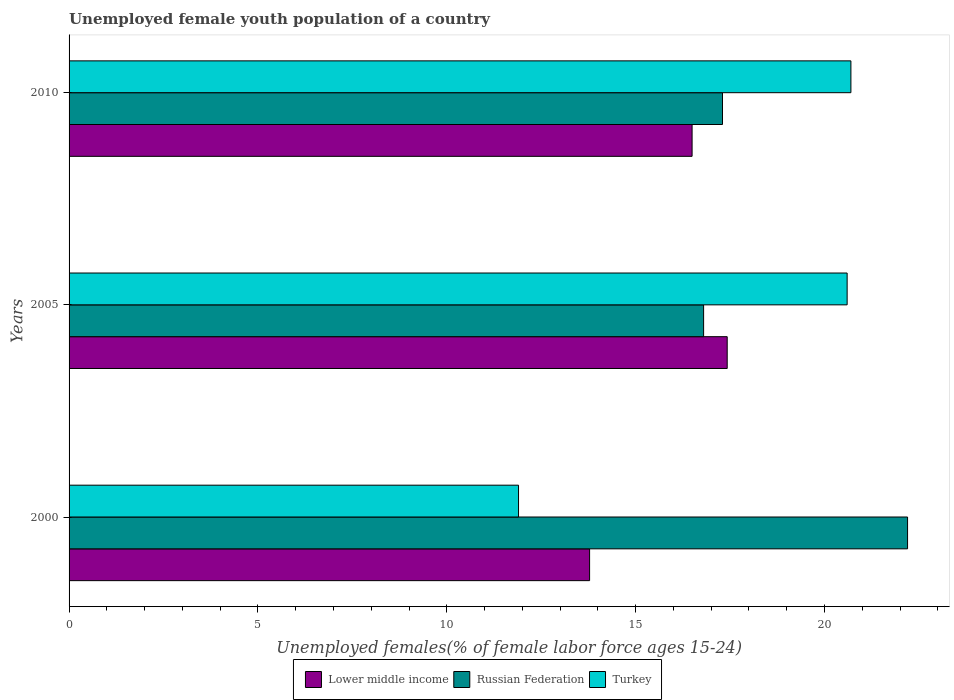How many different coloured bars are there?
Give a very brief answer. 3. How many bars are there on the 1st tick from the bottom?
Give a very brief answer. 3. What is the percentage of unemployed female youth population in Russian Federation in 2010?
Provide a succinct answer. 17.3. Across all years, what is the maximum percentage of unemployed female youth population in Lower middle income?
Ensure brevity in your answer.  17.42. Across all years, what is the minimum percentage of unemployed female youth population in Turkey?
Make the answer very short. 11.9. In which year was the percentage of unemployed female youth population in Lower middle income maximum?
Ensure brevity in your answer.  2005. What is the total percentage of unemployed female youth population in Russian Federation in the graph?
Your response must be concise. 56.3. What is the difference between the percentage of unemployed female youth population in Turkey in 2005 and that in 2010?
Your answer should be very brief. -0.1. What is the difference between the percentage of unemployed female youth population in Russian Federation in 2010 and the percentage of unemployed female youth population in Turkey in 2000?
Offer a very short reply. 5.4. What is the average percentage of unemployed female youth population in Russian Federation per year?
Provide a succinct answer. 18.77. In the year 2005, what is the difference between the percentage of unemployed female youth population in Russian Federation and percentage of unemployed female youth population in Lower middle income?
Give a very brief answer. -0.62. In how many years, is the percentage of unemployed female youth population in Russian Federation greater than 18 %?
Ensure brevity in your answer.  1. What is the ratio of the percentage of unemployed female youth population in Russian Federation in 2000 to that in 2010?
Provide a short and direct response. 1.28. What is the difference between the highest and the second highest percentage of unemployed female youth population in Turkey?
Provide a succinct answer. 0.1. What is the difference between the highest and the lowest percentage of unemployed female youth population in Russian Federation?
Your answer should be compact. 5.4. In how many years, is the percentage of unemployed female youth population in Turkey greater than the average percentage of unemployed female youth population in Turkey taken over all years?
Give a very brief answer. 2. Is the sum of the percentage of unemployed female youth population in Turkey in 2005 and 2010 greater than the maximum percentage of unemployed female youth population in Russian Federation across all years?
Make the answer very short. Yes. What does the 2nd bar from the top in 2005 represents?
Your response must be concise. Russian Federation. What does the 2nd bar from the bottom in 2000 represents?
Your answer should be compact. Russian Federation. How many years are there in the graph?
Offer a very short reply. 3. What is the difference between two consecutive major ticks on the X-axis?
Give a very brief answer. 5. Does the graph contain any zero values?
Offer a terse response. No. Does the graph contain grids?
Provide a short and direct response. No. Where does the legend appear in the graph?
Offer a very short reply. Bottom center. How many legend labels are there?
Offer a terse response. 3. How are the legend labels stacked?
Give a very brief answer. Horizontal. What is the title of the graph?
Make the answer very short. Unemployed female youth population of a country. Does "New Zealand" appear as one of the legend labels in the graph?
Your response must be concise. No. What is the label or title of the X-axis?
Make the answer very short. Unemployed females(% of female labor force ages 15-24). What is the Unemployed females(% of female labor force ages 15-24) of Lower middle income in 2000?
Provide a succinct answer. 13.78. What is the Unemployed females(% of female labor force ages 15-24) in Russian Federation in 2000?
Provide a succinct answer. 22.2. What is the Unemployed females(% of female labor force ages 15-24) of Turkey in 2000?
Keep it short and to the point. 11.9. What is the Unemployed females(% of female labor force ages 15-24) in Lower middle income in 2005?
Provide a succinct answer. 17.42. What is the Unemployed females(% of female labor force ages 15-24) in Russian Federation in 2005?
Keep it short and to the point. 16.8. What is the Unemployed females(% of female labor force ages 15-24) in Turkey in 2005?
Make the answer very short. 20.6. What is the Unemployed females(% of female labor force ages 15-24) of Lower middle income in 2010?
Provide a short and direct response. 16.49. What is the Unemployed females(% of female labor force ages 15-24) in Russian Federation in 2010?
Keep it short and to the point. 17.3. What is the Unemployed females(% of female labor force ages 15-24) of Turkey in 2010?
Ensure brevity in your answer.  20.7. Across all years, what is the maximum Unemployed females(% of female labor force ages 15-24) of Lower middle income?
Offer a terse response. 17.42. Across all years, what is the maximum Unemployed females(% of female labor force ages 15-24) of Russian Federation?
Your answer should be very brief. 22.2. Across all years, what is the maximum Unemployed females(% of female labor force ages 15-24) of Turkey?
Give a very brief answer. 20.7. Across all years, what is the minimum Unemployed females(% of female labor force ages 15-24) of Lower middle income?
Provide a succinct answer. 13.78. Across all years, what is the minimum Unemployed females(% of female labor force ages 15-24) of Russian Federation?
Offer a terse response. 16.8. Across all years, what is the minimum Unemployed females(% of female labor force ages 15-24) of Turkey?
Give a very brief answer. 11.9. What is the total Unemployed females(% of female labor force ages 15-24) of Lower middle income in the graph?
Your response must be concise. 47.7. What is the total Unemployed females(% of female labor force ages 15-24) of Russian Federation in the graph?
Make the answer very short. 56.3. What is the total Unemployed females(% of female labor force ages 15-24) of Turkey in the graph?
Offer a terse response. 53.2. What is the difference between the Unemployed females(% of female labor force ages 15-24) of Lower middle income in 2000 and that in 2005?
Provide a short and direct response. -3.64. What is the difference between the Unemployed females(% of female labor force ages 15-24) of Turkey in 2000 and that in 2005?
Offer a very short reply. -8.7. What is the difference between the Unemployed females(% of female labor force ages 15-24) of Lower middle income in 2000 and that in 2010?
Your answer should be very brief. -2.71. What is the difference between the Unemployed females(% of female labor force ages 15-24) of Russian Federation in 2000 and that in 2010?
Your answer should be compact. 4.9. What is the difference between the Unemployed females(% of female labor force ages 15-24) in Turkey in 2000 and that in 2010?
Your response must be concise. -8.8. What is the difference between the Unemployed females(% of female labor force ages 15-24) of Lower middle income in 2005 and that in 2010?
Your answer should be very brief. 0.93. What is the difference between the Unemployed females(% of female labor force ages 15-24) in Turkey in 2005 and that in 2010?
Your answer should be compact. -0.1. What is the difference between the Unemployed females(% of female labor force ages 15-24) in Lower middle income in 2000 and the Unemployed females(% of female labor force ages 15-24) in Russian Federation in 2005?
Give a very brief answer. -3.02. What is the difference between the Unemployed females(% of female labor force ages 15-24) of Lower middle income in 2000 and the Unemployed females(% of female labor force ages 15-24) of Turkey in 2005?
Provide a succinct answer. -6.82. What is the difference between the Unemployed females(% of female labor force ages 15-24) in Russian Federation in 2000 and the Unemployed females(% of female labor force ages 15-24) in Turkey in 2005?
Offer a terse response. 1.6. What is the difference between the Unemployed females(% of female labor force ages 15-24) in Lower middle income in 2000 and the Unemployed females(% of female labor force ages 15-24) in Russian Federation in 2010?
Your response must be concise. -3.52. What is the difference between the Unemployed females(% of female labor force ages 15-24) of Lower middle income in 2000 and the Unemployed females(% of female labor force ages 15-24) of Turkey in 2010?
Your response must be concise. -6.92. What is the difference between the Unemployed females(% of female labor force ages 15-24) of Lower middle income in 2005 and the Unemployed females(% of female labor force ages 15-24) of Russian Federation in 2010?
Offer a terse response. 0.12. What is the difference between the Unemployed females(% of female labor force ages 15-24) of Lower middle income in 2005 and the Unemployed females(% of female labor force ages 15-24) of Turkey in 2010?
Offer a terse response. -3.28. What is the difference between the Unemployed females(% of female labor force ages 15-24) in Russian Federation in 2005 and the Unemployed females(% of female labor force ages 15-24) in Turkey in 2010?
Provide a short and direct response. -3.9. What is the average Unemployed females(% of female labor force ages 15-24) of Lower middle income per year?
Ensure brevity in your answer.  15.9. What is the average Unemployed females(% of female labor force ages 15-24) of Russian Federation per year?
Ensure brevity in your answer.  18.77. What is the average Unemployed females(% of female labor force ages 15-24) in Turkey per year?
Your answer should be compact. 17.73. In the year 2000, what is the difference between the Unemployed females(% of female labor force ages 15-24) in Lower middle income and Unemployed females(% of female labor force ages 15-24) in Russian Federation?
Provide a short and direct response. -8.42. In the year 2000, what is the difference between the Unemployed females(% of female labor force ages 15-24) in Lower middle income and Unemployed females(% of female labor force ages 15-24) in Turkey?
Provide a short and direct response. 1.88. In the year 2000, what is the difference between the Unemployed females(% of female labor force ages 15-24) in Russian Federation and Unemployed females(% of female labor force ages 15-24) in Turkey?
Your response must be concise. 10.3. In the year 2005, what is the difference between the Unemployed females(% of female labor force ages 15-24) in Lower middle income and Unemployed females(% of female labor force ages 15-24) in Russian Federation?
Provide a short and direct response. 0.62. In the year 2005, what is the difference between the Unemployed females(% of female labor force ages 15-24) of Lower middle income and Unemployed females(% of female labor force ages 15-24) of Turkey?
Your response must be concise. -3.18. In the year 2005, what is the difference between the Unemployed females(% of female labor force ages 15-24) in Russian Federation and Unemployed females(% of female labor force ages 15-24) in Turkey?
Ensure brevity in your answer.  -3.8. In the year 2010, what is the difference between the Unemployed females(% of female labor force ages 15-24) in Lower middle income and Unemployed females(% of female labor force ages 15-24) in Russian Federation?
Offer a terse response. -0.81. In the year 2010, what is the difference between the Unemployed females(% of female labor force ages 15-24) in Lower middle income and Unemployed females(% of female labor force ages 15-24) in Turkey?
Your answer should be very brief. -4.21. What is the ratio of the Unemployed females(% of female labor force ages 15-24) in Lower middle income in 2000 to that in 2005?
Keep it short and to the point. 0.79. What is the ratio of the Unemployed females(% of female labor force ages 15-24) in Russian Federation in 2000 to that in 2005?
Provide a short and direct response. 1.32. What is the ratio of the Unemployed females(% of female labor force ages 15-24) of Turkey in 2000 to that in 2005?
Keep it short and to the point. 0.58. What is the ratio of the Unemployed females(% of female labor force ages 15-24) of Lower middle income in 2000 to that in 2010?
Your answer should be compact. 0.84. What is the ratio of the Unemployed females(% of female labor force ages 15-24) of Russian Federation in 2000 to that in 2010?
Ensure brevity in your answer.  1.28. What is the ratio of the Unemployed females(% of female labor force ages 15-24) in Turkey in 2000 to that in 2010?
Offer a very short reply. 0.57. What is the ratio of the Unemployed females(% of female labor force ages 15-24) in Lower middle income in 2005 to that in 2010?
Offer a terse response. 1.06. What is the ratio of the Unemployed females(% of female labor force ages 15-24) in Russian Federation in 2005 to that in 2010?
Provide a succinct answer. 0.97. What is the difference between the highest and the second highest Unemployed females(% of female labor force ages 15-24) in Lower middle income?
Make the answer very short. 0.93. What is the difference between the highest and the second highest Unemployed females(% of female labor force ages 15-24) of Russian Federation?
Keep it short and to the point. 4.9. What is the difference between the highest and the lowest Unemployed females(% of female labor force ages 15-24) in Lower middle income?
Provide a succinct answer. 3.64. What is the difference between the highest and the lowest Unemployed females(% of female labor force ages 15-24) of Turkey?
Provide a short and direct response. 8.8. 